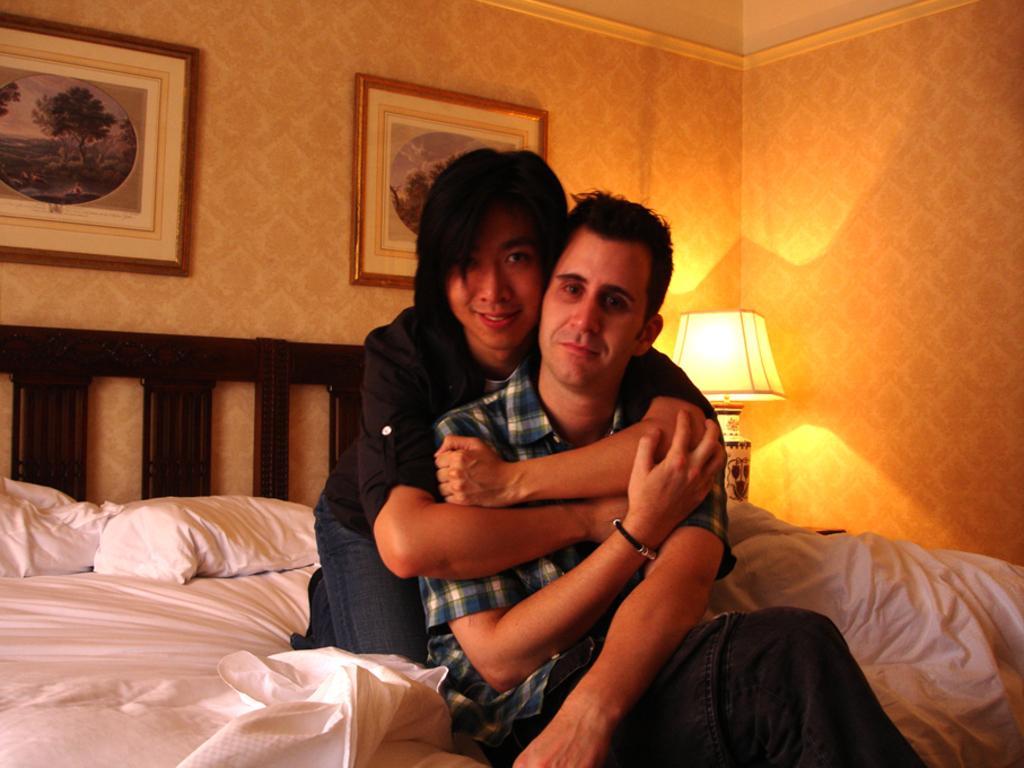How would you summarize this image in a sentence or two? In the middle of the image two persons are sitting on the bed. Behind the bed there is a table, on the table there is a lamp. At the top of the image there is a wall, on the wall there are two frames. 